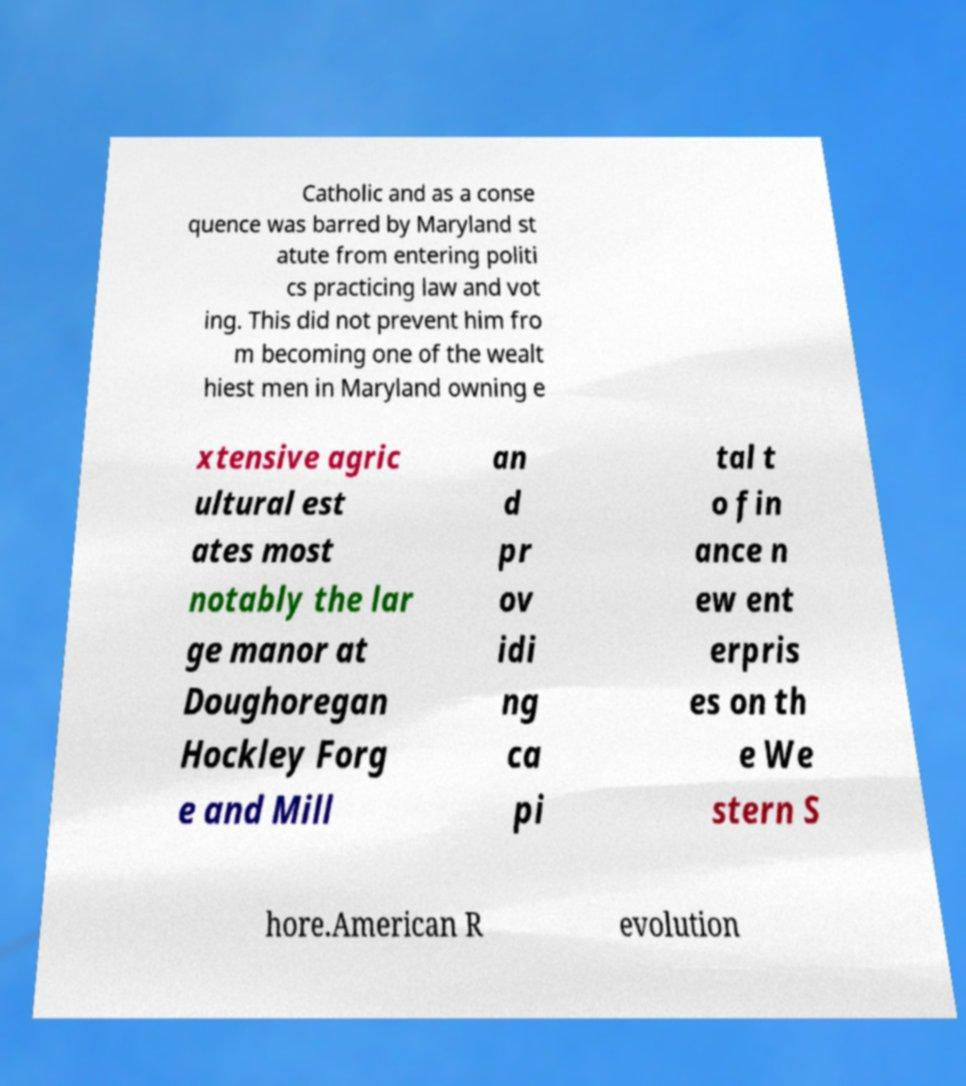Please identify and transcribe the text found in this image. Catholic and as a conse quence was barred by Maryland st atute from entering politi cs practicing law and vot ing. This did not prevent him fro m becoming one of the wealt hiest men in Maryland owning e xtensive agric ultural est ates most notably the lar ge manor at Doughoregan Hockley Forg e and Mill an d pr ov idi ng ca pi tal t o fin ance n ew ent erpris es on th e We stern S hore.American R evolution 